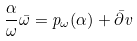<formula> <loc_0><loc_0><loc_500><loc_500>\frac { \alpha } { \omega } \bar { \omega } = p _ { \omega } ( \alpha ) + \bar { \partial } v</formula> 